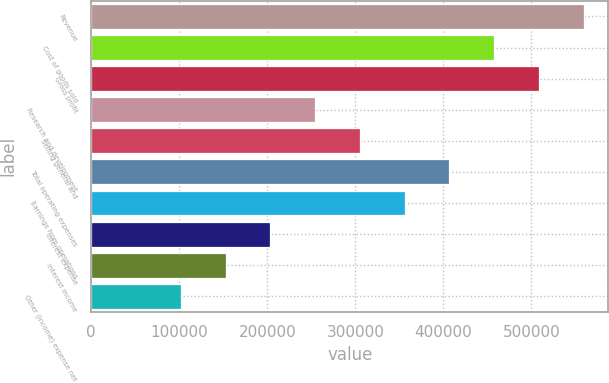Convert chart. <chart><loc_0><loc_0><loc_500><loc_500><bar_chart><fcel>Revenue<fcel>Cost of goods sold<fcel>Gross profit<fcel>Research and development<fcel>Selling general and<fcel>Total operating expenses<fcel>Earnings from operations<fcel>Interest expense<fcel>Interest income<fcel>Other (income) expense net<nl><fcel>559417<fcel>457705<fcel>508561<fcel>254281<fcel>305137<fcel>406849<fcel>355993<fcel>203425<fcel>152569<fcel>101713<nl></chart> 